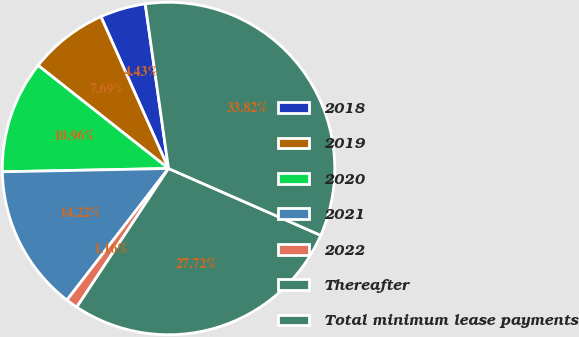Convert chart. <chart><loc_0><loc_0><loc_500><loc_500><pie_chart><fcel>2018<fcel>2019<fcel>2020<fcel>2021<fcel>2022<fcel>Thereafter<fcel>Total minimum lease payments<nl><fcel>4.43%<fcel>7.69%<fcel>10.96%<fcel>14.22%<fcel>1.16%<fcel>27.72%<fcel>33.82%<nl></chart> 